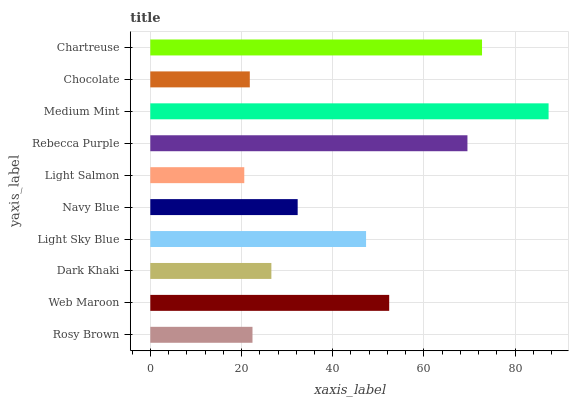Is Light Salmon the minimum?
Answer yes or no. Yes. Is Medium Mint the maximum?
Answer yes or no. Yes. Is Web Maroon the minimum?
Answer yes or no. No. Is Web Maroon the maximum?
Answer yes or no. No. Is Web Maroon greater than Rosy Brown?
Answer yes or no. Yes. Is Rosy Brown less than Web Maroon?
Answer yes or no. Yes. Is Rosy Brown greater than Web Maroon?
Answer yes or no. No. Is Web Maroon less than Rosy Brown?
Answer yes or no. No. Is Light Sky Blue the high median?
Answer yes or no. Yes. Is Navy Blue the low median?
Answer yes or no. Yes. Is Web Maroon the high median?
Answer yes or no. No. Is Chartreuse the low median?
Answer yes or no. No. 